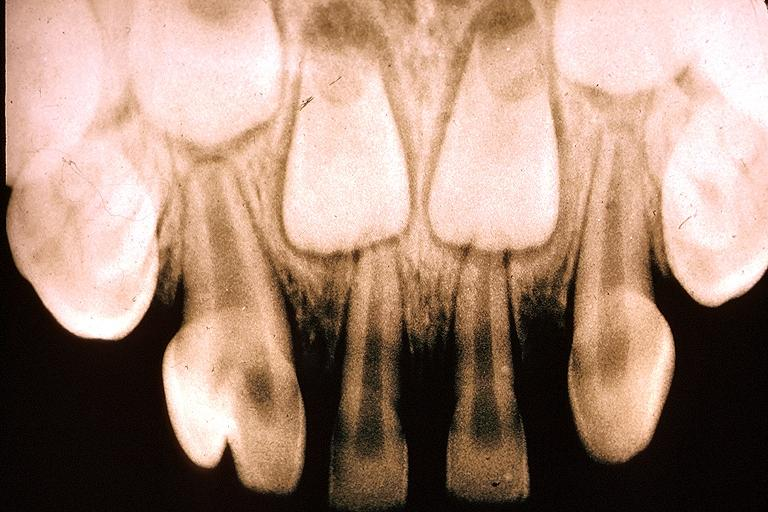what does this image show?
Answer the question using a single word or phrase. Gemination 